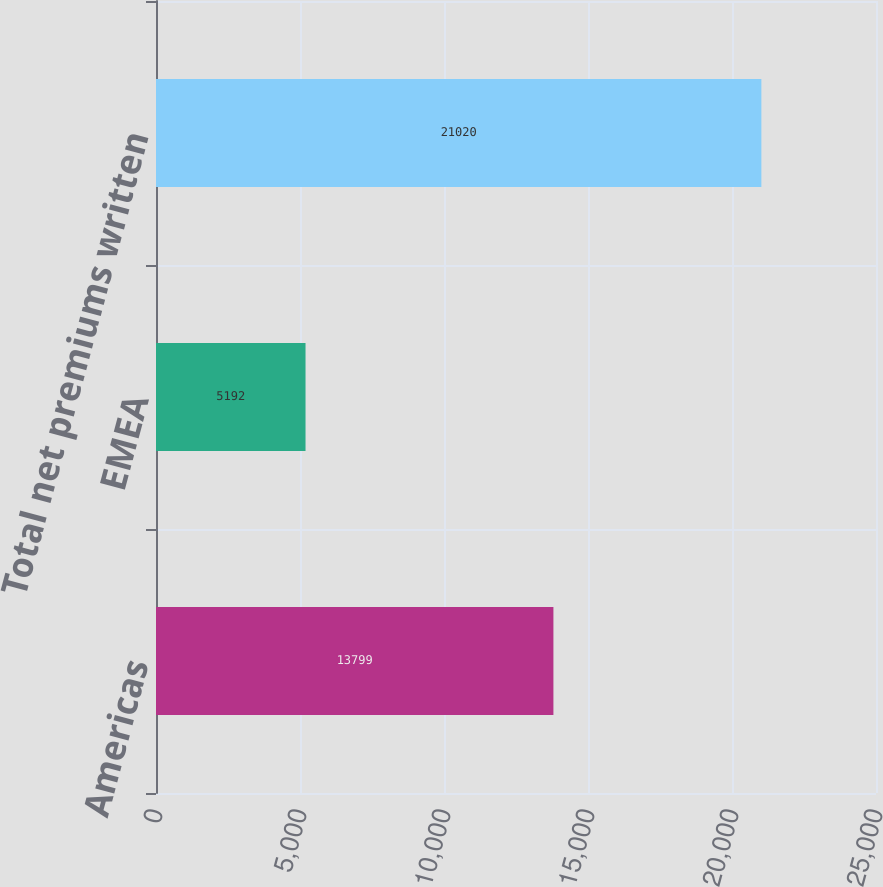Convert chart. <chart><loc_0><loc_0><loc_500><loc_500><bar_chart><fcel>Americas<fcel>EMEA<fcel>Total net premiums written<nl><fcel>13799<fcel>5192<fcel>21020<nl></chart> 